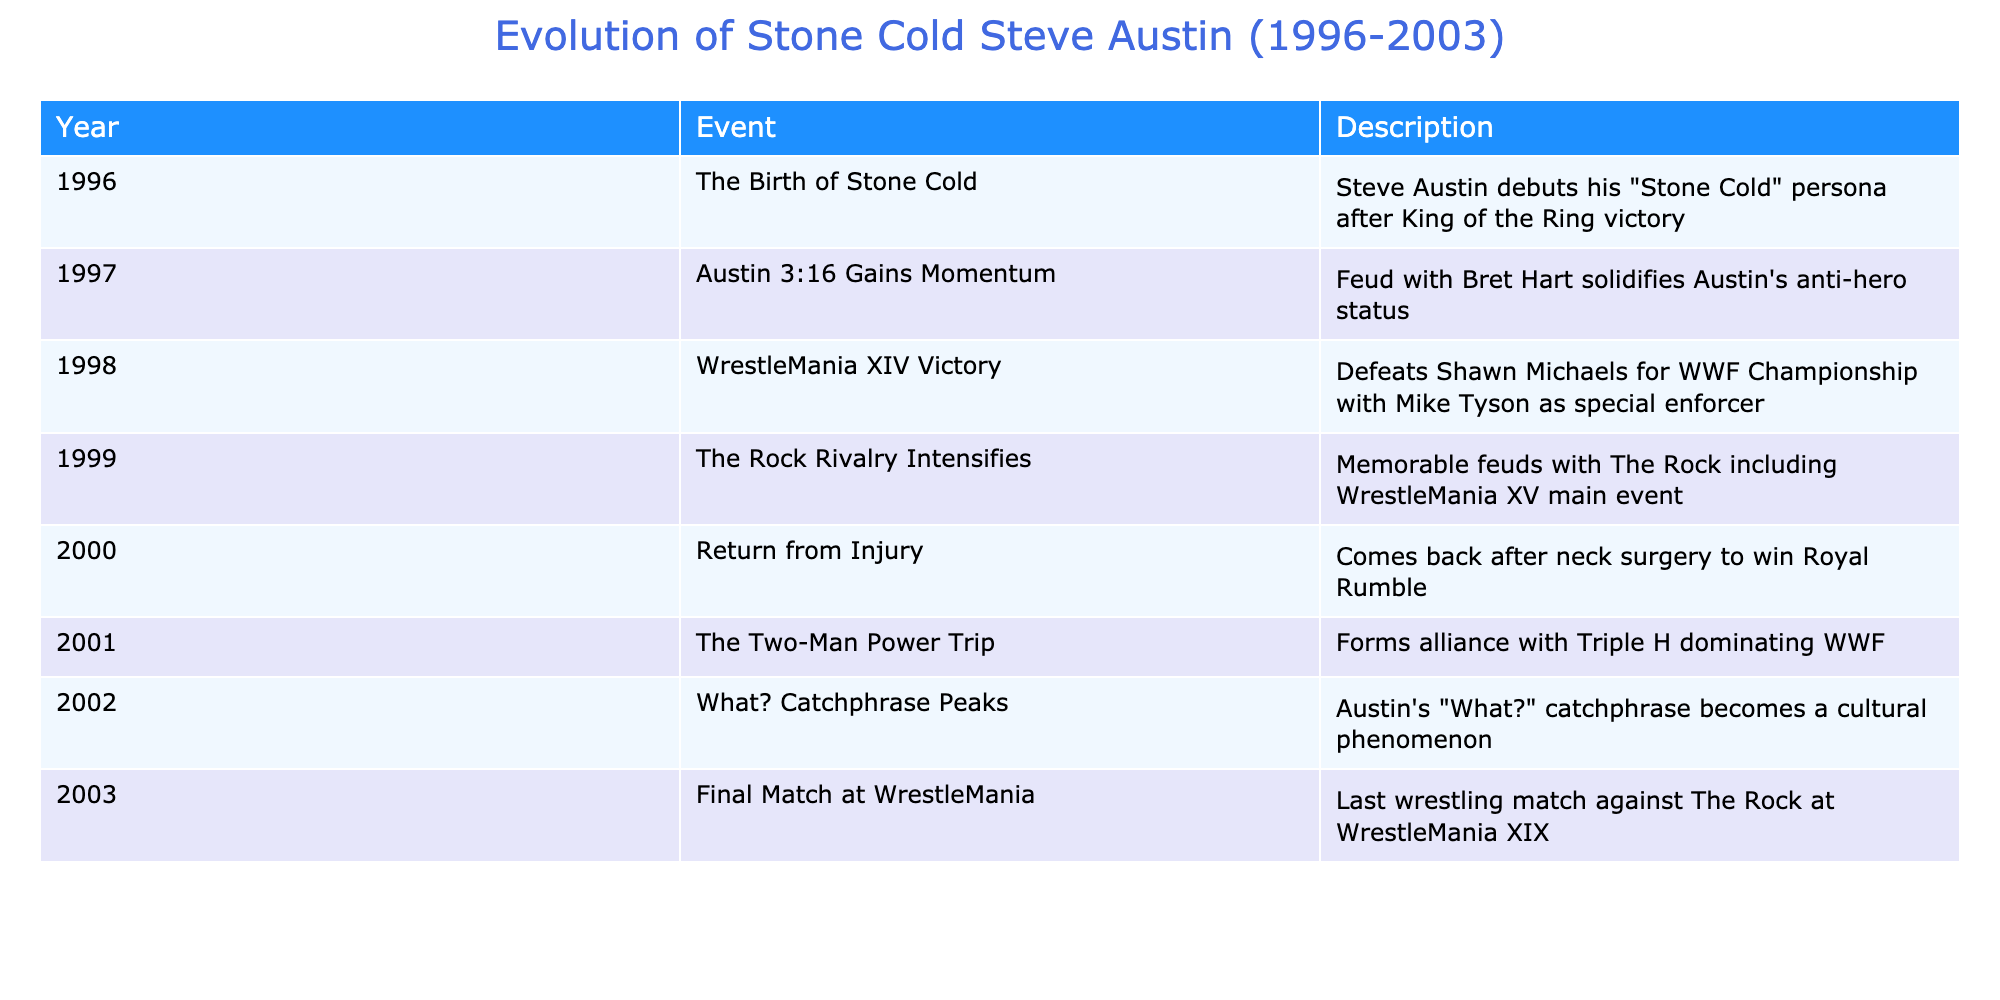What year did Stone Cold win the WWF Championship? The table shows that Stone Cold Steve Austin won the WWF Championship in 1998, as indicated in the event related to WrestleMania XIV.
Answer: 1998 What was the notable event in 1999 involving The Rock? The table states that in 1999, there was a rivalry that intensified with The Rock, including a memorable main event at WrestleMania XV. This highlights the significance of this rivalry that year.
Answer: Memorable feuds at WrestleMania XV In which year did Stone Cold's "What?" catchphrase become a cultural phenomenon? The table clearly states that the "What?" catchphrase peaked in 2002.
Answer: 2002 How many years passed between the debut of Stone Cold and his last match? Stone Cold debuted in 1996 and had his final match in 2003. The difference is 2003 - 1996 = 7 years.
Answer: 7 years Did Stone Cold have a feud with Bret Hart? Yes, the table indicates that the feud with Bret Hart in 1997 was significant in solidifying Austin's anti-hero status, confirming this fact.
Answer: Yes What was the nature of the alliance Stone Cold formed in 2001? The data states that in 2001, Stone Cold formed an alliance with Triple H, which led to their dominance in WWF, indicating a powerful partnership.
Answer: Alliance with Triple H Which event marked the beginning of Stone Cold's "Stone Cold" persona? According to the table, Stone Cold's persona began with his debut after winning King of the Ring in 1996, marking a pivotal moment in his career.
Answer: King of the Ring victory What two major events occurred in 1998 according to the table? The table shows that in 1998, Stone Cold defeated Shawn Michaels at WrestleMania XIV for the WWF Championship and also features Mike Tyson as a special enforcer, marking it as a significant year.
Answer: WWF Championship win and Mike Tyson involvement 